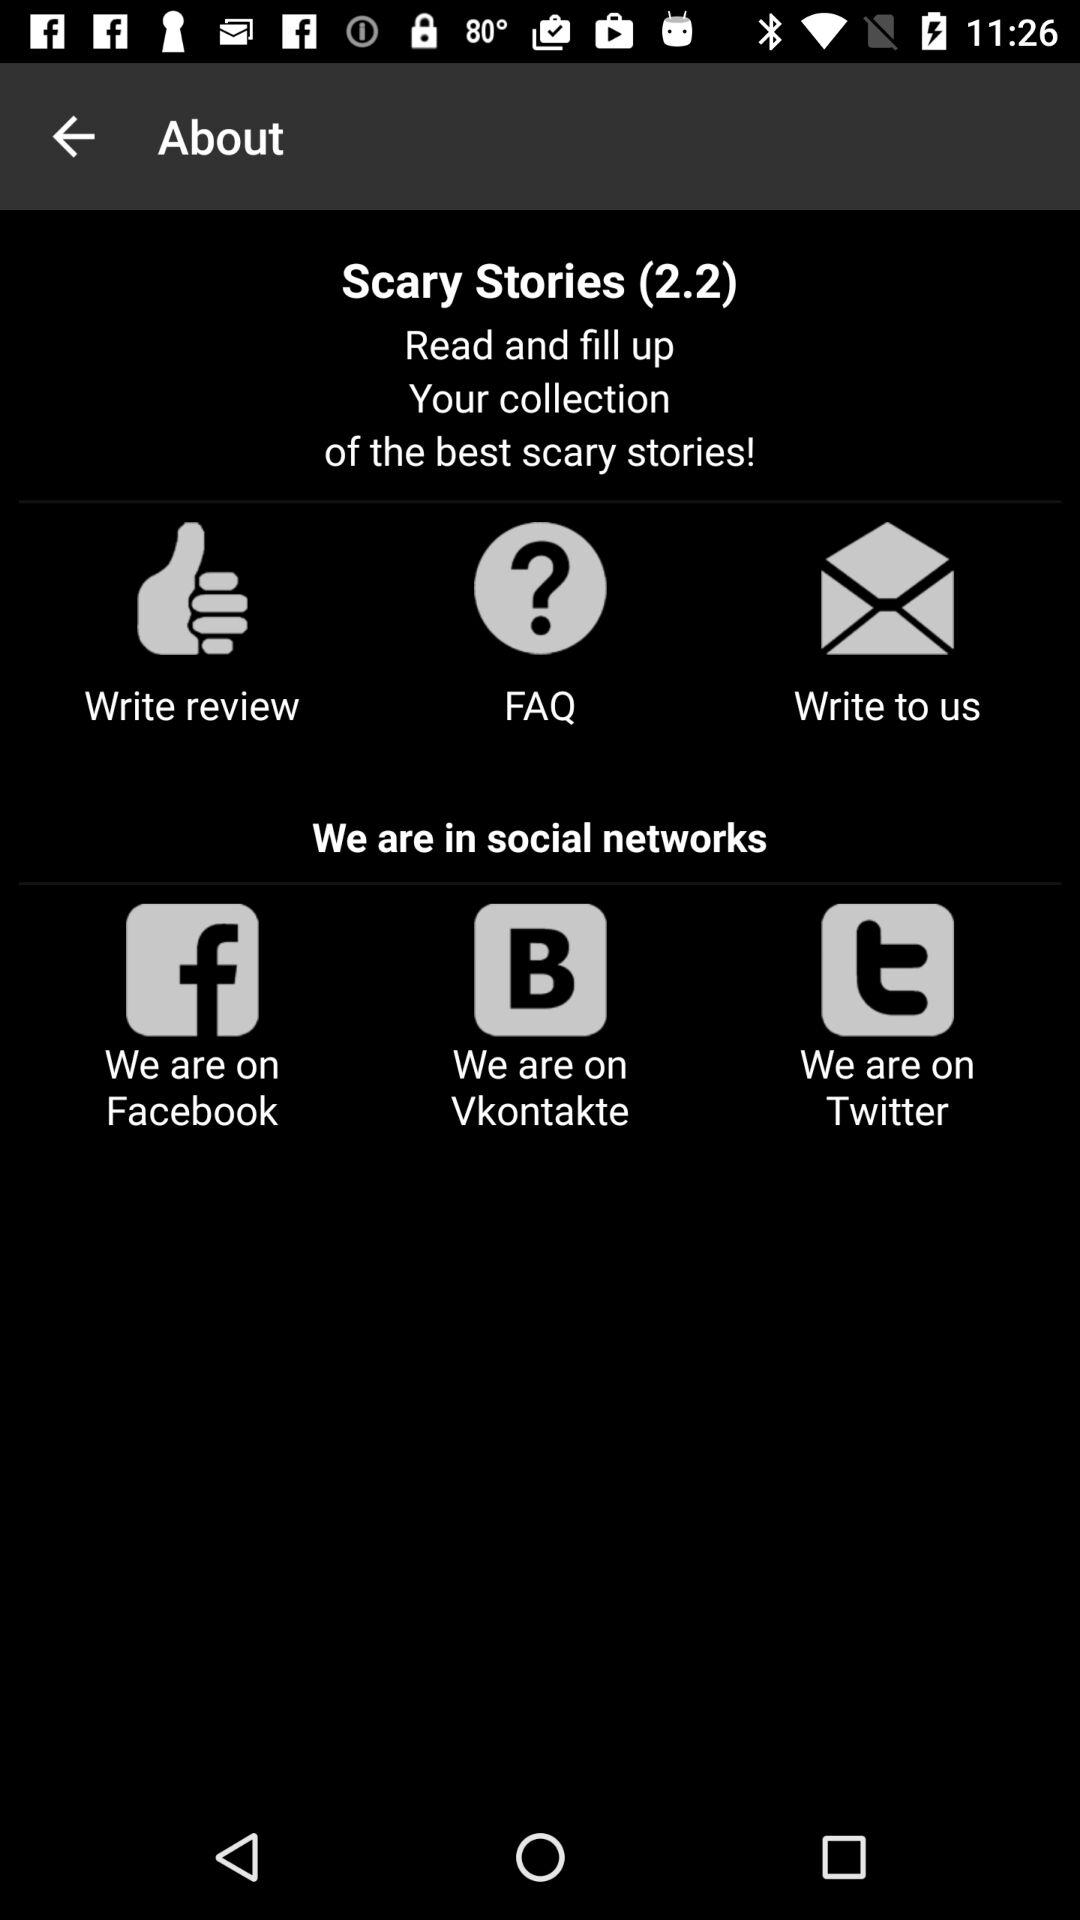How many social networks are the app present in?
Answer the question using a single word or phrase. 3 